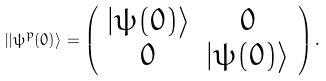<formula> <loc_0><loc_0><loc_500><loc_500>| | \psi ^ { p } ( 0 ) \rangle = \left ( \begin{array} { c c c c c c } | \psi ( 0 ) \rangle & 0 \\ 0 & | \psi ( 0 ) \rangle \\ \end{array} \right ) .</formula> 